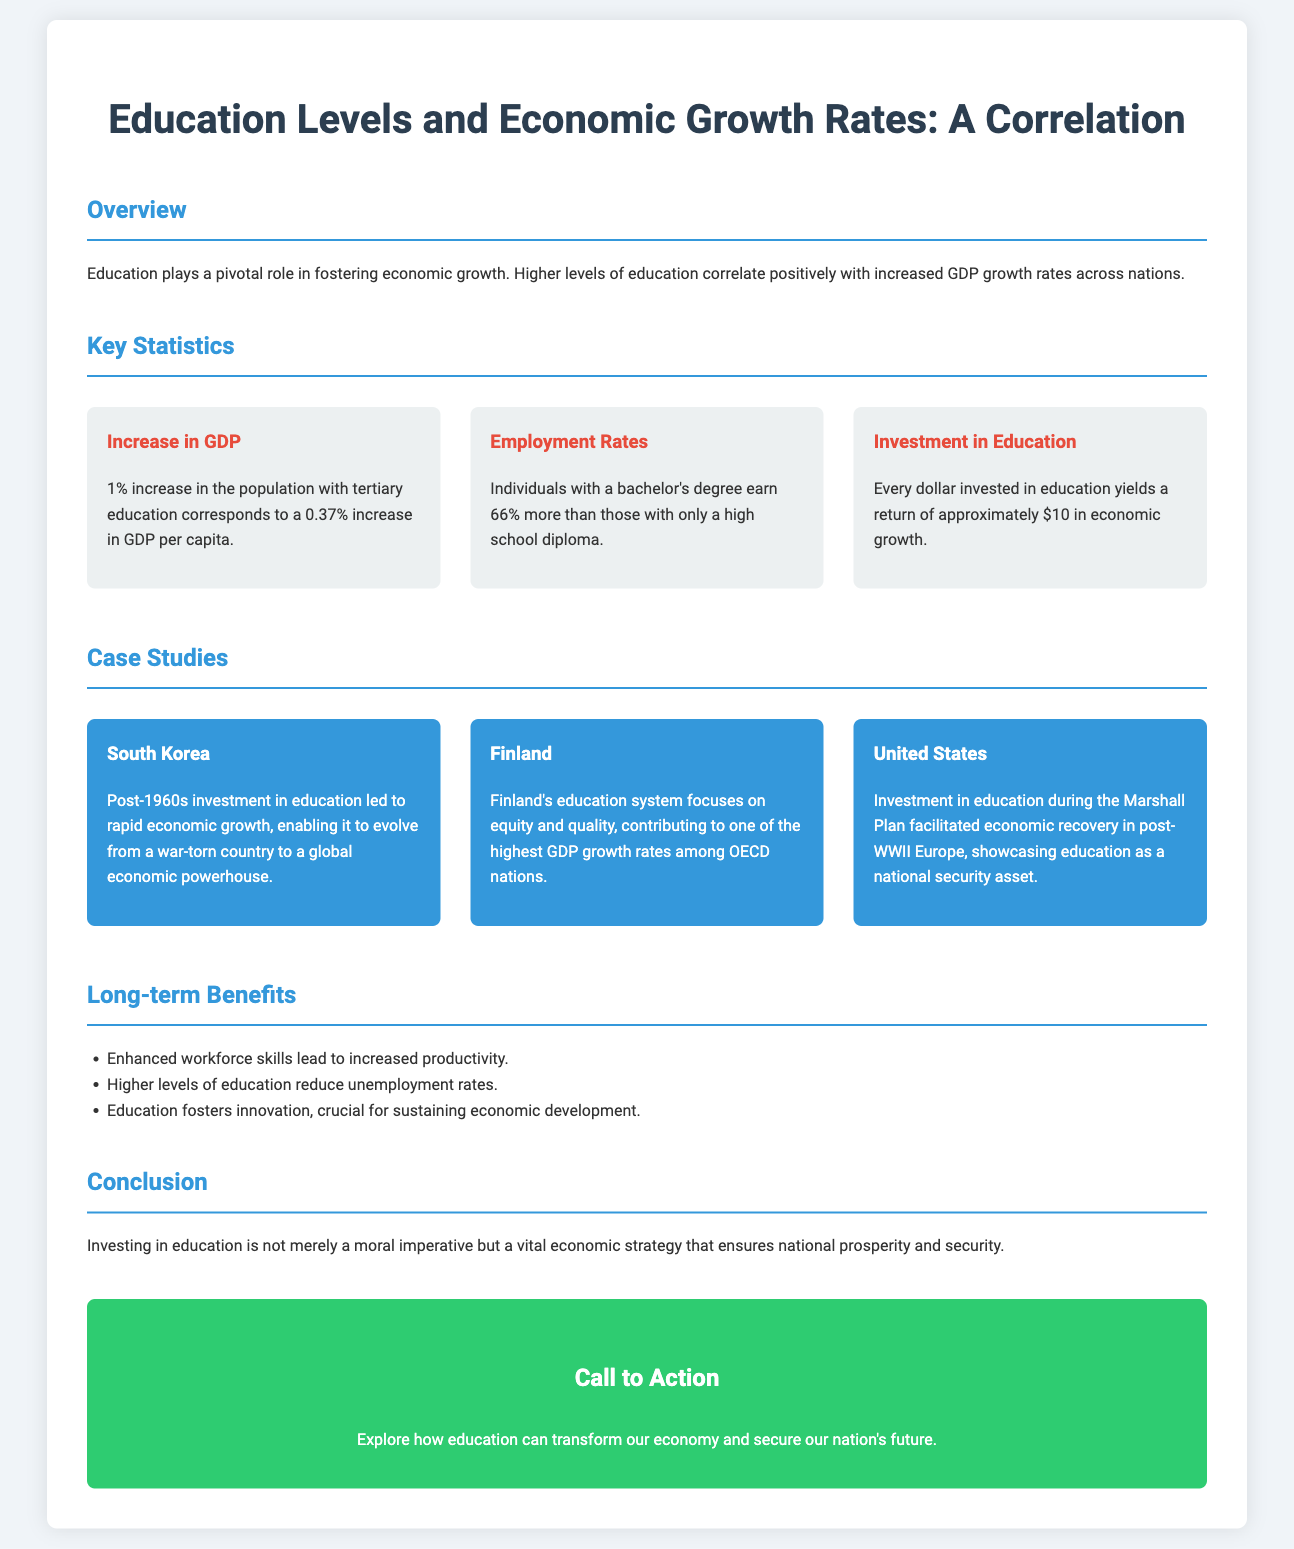What is the impact of a 1% increase in the population with tertiary education on GDP per capita? The document states that a 1% increase corresponds to a 0.37% increase in GDP per capita.
Answer: 0.37% What is the percentage increase in earnings for individuals with a bachelor's degree compared to those with only a high school diploma? According to the document, individuals with a bachelor's degree earn 66% more than those with only a high school diploma.
Answer: 66% How much economic growth does every dollar invested in education yield? The document mentions that every dollar invested in education yields a return of approximately $10 in economic growth.
Answer: $10 Which country evolved into a global economic powerhouse due to post-1960s investment in education? The case study mentions South Korea as the country that transformed through education investment.
Answer: South Korea What does Finland’s education system prioritize according to the document? The document highlights that Finland's education system focuses on equity and quality.
Answer: Equity and quality What was showcased as a national security asset during the post-WWII recovery in Europe? The document cites investment in education as a vital national security asset during the Marshall Plan.
Answer: Investment in education Which section discusses the long-term benefits of investing in education? The document explicitly mentions the "Long-term Benefits" section.
Answer: Long-term Benefits What is the overall conclusion about investing in education? The conclusion emphasizes that investing in education ensures national prosperity and security.
Answer: National prosperity and security 